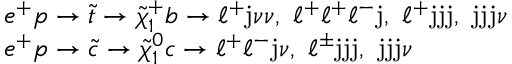<formula> <loc_0><loc_0><loc_500><loc_500>\begin{array} { l } { { e ^ { + } p \rightarrow \tilde { t } \rightarrow \tilde { \chi } _ { 1 } ^ { + } b \rightarrow \ell ^ { + } j \nu \nu , \ell ^ { + } \ell ^ { + } \ell ^ { - } j , \ell ^ { + } j j j , j j j \nu } } \\ { { e ^ { + } p \rightarrow \tilde { c } \rightarrow \tilde { \chi } _ { 1 } ^ { 0 } c \rightarrow \ell ^ { + } \ell ^ { - } j \nu , \ell ^ { \pm } j j j , j j j \nu } } \end{array}</formula> 